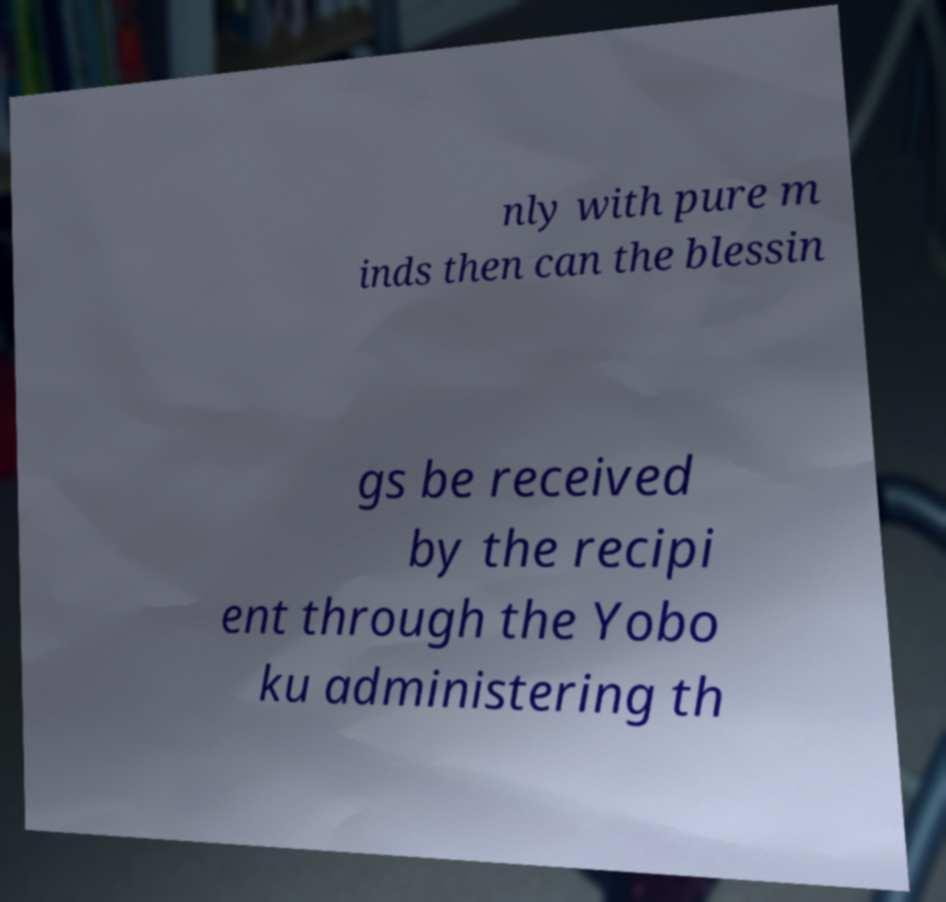Could you assist in decoding the text presented in this image and type it out clearly? nly with pure m inds then can the blessin gs be received by the recipi ent through the Yobo ku administering th 